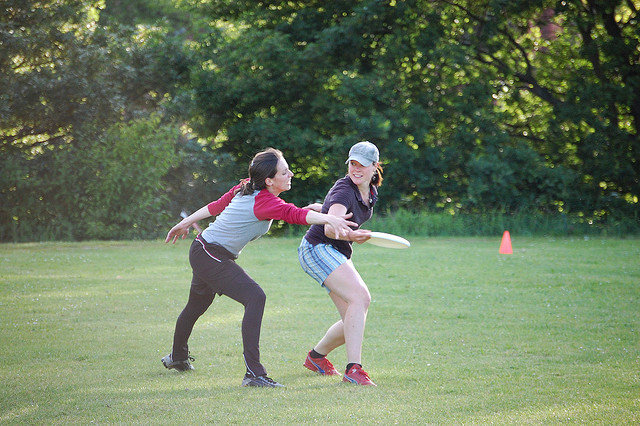<image>Why do the young men have ethereal doubles? It is unknown why the young men have ethereal doubles, because the men are not visible in the image. Why do the young men have ethereal doubles? I don't know why the young men have ethereal doubles. It is not possible to determine the reason without further information. 